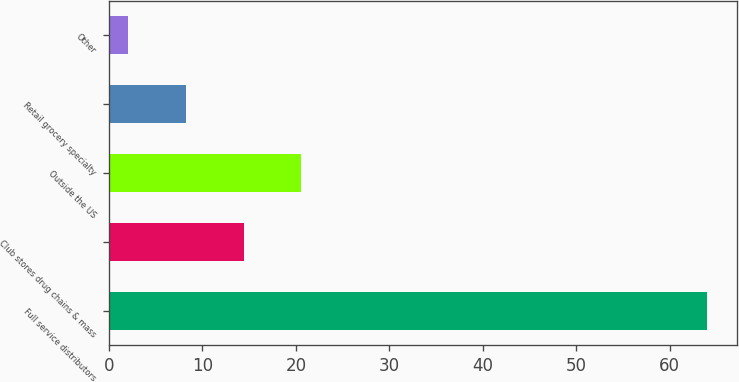<chart> <loc_0><loc_0><loc_500><loc_500><bar_chart><fcel>Full service distributors<fcel>Club stores drug chains & mass<fcel>Outside the US<fcel>Retail grocery specialty<fcel>Other<nl><fcel>64<fcel>14.4<fcel>20.6<fcel>8.2<fcel>2<nl></chart> 